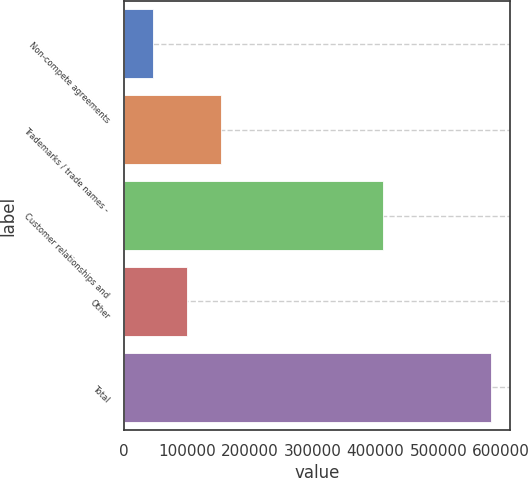Convert chart to OTSL. <chart><loc_0><loc_0><loc_500><loc_500><bar_chart><fcel>Non-compete agreements<fcel>Trademarks / trade names -<fcel>Customer relationships and<fcel>Other<fcel>Total<nl><fcel>46327<fcel>153861<fcel>412194<fcel>100094<fcel>583995<nl></chart> 